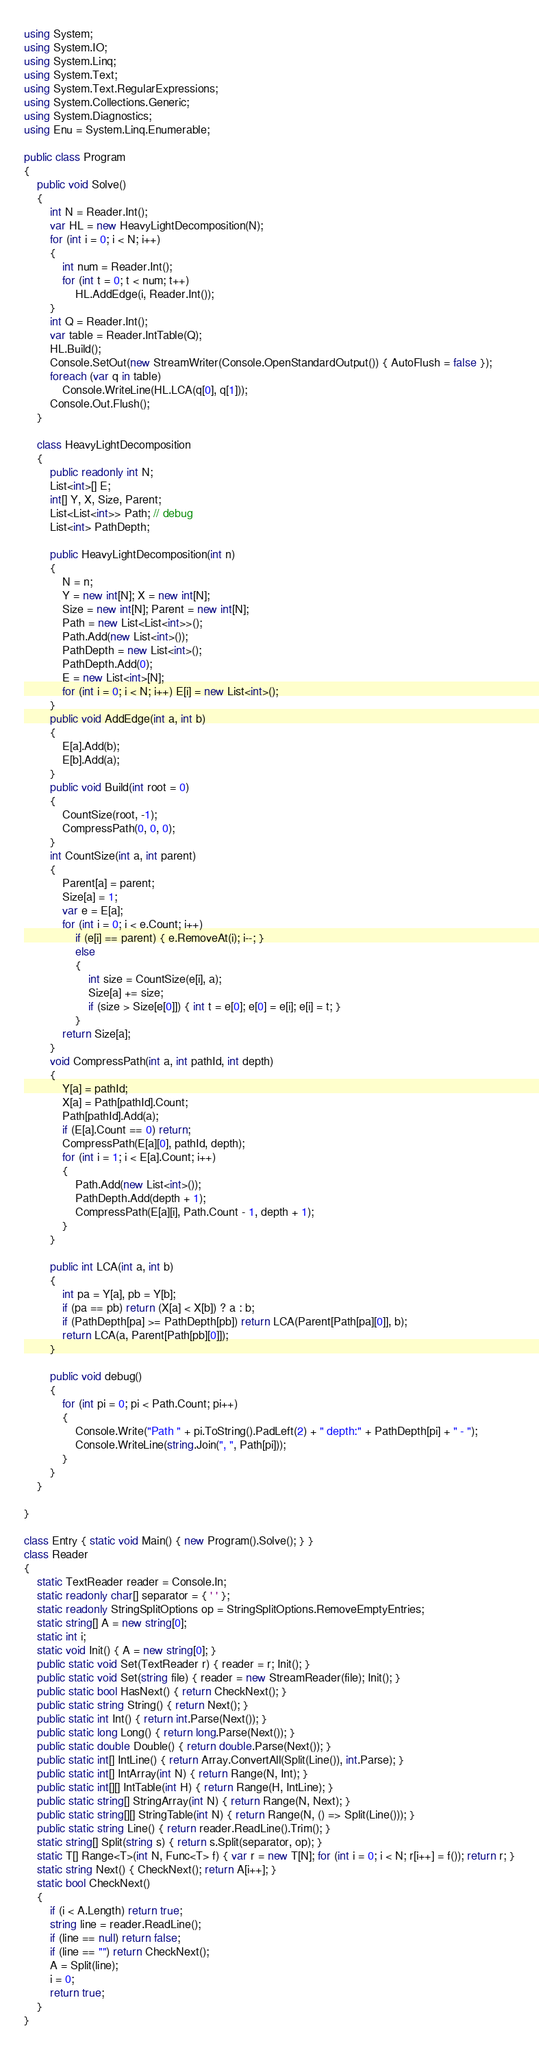<code> <loc_0><loc_0><loc_500><loc_500><_C#_>using System;
using System.IO;
using System.Linq;
using System.Text;
using System.Text.RegularExpressions;
using System.Collections.Generic;
using System.Diagnostics;
using Enu = System.Linq.Enumerable;

public class Program
{
    public void Solve()
    {
        int N = Reader.Int();
        var HL = new HeavyLightDecomposition(N);
        for (int i = 0; i < N; i++)
        {
            int num = Reader.Int();
            for (int t = 0; t < num; t++)
                HL.AddEdge(i, Reader.Int());
        }
        int Q = Reader.Int();
        var table = Reader.IntTable(Q);
        HL.Build();
        Console.SetOut(new StreamWriter(Console.OpenStandardOutput()) { AutoFlush = false });
        foreach (var q in table)
            Console.WriteLine(HL.LCA(q[0], q[1]));
        Console.Out.Flush();
    }

    class HeavyLightDecomposition
    {
        public readonly int N;
        List<int>[] E;
        int[] Y, X, Size, Parent;
        List<List<int>> Path; // debug
        List<int> PathDepth;

        public HeavyLightDecomposition(int n)
        {
            N = n;
            Y = new int[N]; X = new int[N];
            Size = new int[N]; Parent = new int[N];
            Path = new List<List<int>>();
            Path.Add(new List<int>());
            PathDepth = new List<int>();
            PathDepth.Add(0);
            E = new List<int>[N];
            for (int i = 0; i < N; i++) E[i] = new List<int>();
        }
        public void AddEdge(int a, int b)
        {
            E[a].Add(b);
            E[b].Add(a);
        }
        public void Build(int root = 0)
        {
            CountSize(root, -1);
            CompressPath(0, 0, 0);
        }
        int CountSize(int a, int parent)
        {
            Parent[a] = parent;
            Size[a] = 1;
            var e = E[a];
            for (int i = 0; i < e.Count; i++)
                if (e[i] == parent) { e.RemoveAt(i); i--; }
                else
                {
                    int size = CountSize(e[i], a);
                    Size[a] += size;
                    if (size > Size[e[0]]) { int t = e[0]; e[0] = e[i]; e[i] = t; }
                }
            return Size[a];
        }
        void CompressPath(int a, int pathId, int depth)
        {
            Y[a] = pathId;
            X[a] = Path[pathId].Count;
            Path[pathId].Add(a);
            if (E[a].Count == 0) return;
            CompressPath(E[a][0], pathId, depth);
            for (int i = 1; i < E[a].Count; i++)
            {
                Path.Add(new List<int>());
                PathDepth.Add(depth + 1);
                CompressPath(E[a][i], Path.Count - 1, depth + 1);
            }
        }

        public int LCA(int a, int b)
        {
            int pa = Y[a], pb = Y[b];
            if (pa == pb) return (X[a] < X[b]) ? a : b;
            if (PathDepth[pa] >= PathDepth[pb]) return LCA(Parent[Path[pa][0]], b);
            return LCA(a, Parent[Path[pb][0]]);
        }

        public void debug()
        {
            for (int pi = 0; pi < Path.Count; pi++)
            {
                Console.Write("Path " + pi.ToString().PadLeft(2) + " depth:" + PathDepth[pi] + " - ");
                Console.WriteLine(string.Join(", ", Path[pi]));
            }
        }
    }

}

class Entry { static void Main() { new Program().Solve(); } }
class Reader
{
    static TextReader reader = Console.In;
    static readonly char[] separator = { ' ' };
    static readonly StringSplitOptions op = StringSplitOptions.RemoveEmptyEntries;
    static string[] A = new string[0];
    static int i;
    static void Init() { A = new string[0]; }
    public static void Set(TextReader r) { reader = r; Init(); }
    public static void Set(string file) { reader = new StreamReader(file); Init(); }
    public static bool HasNext() { return CheckNext(); }
    public static string String() { return Next(); }
    public static int Int() { return int.Parse(Next()); }
    public static long Long() { return long.Parse(Next()); }
    public static double Double() { return double.Parse(Next()); }
    public static int[] IntLine() { return Array.ConvertAll(Split(Line()), int.Parse); }
    public static int[] IntArray(int N) { return Range(N, Int); }
    public static int[][] IntTable(int H) { return Range(H, IntLine); }
    public static string[] StringArray(int N) { return Range(N, Next); }
    public static string[][] StringTable(int N) { return Range(N, () => Split(Line())); }
    public static string Line() { return reader.ReadLine().Trim(); }
    static string[] Split(string s) { return s.Split(separator, op); }
    static T[] Range<T>(int N, Func<T> f) { var r = new T[N]; for (int i = 0; i < N; r[i++] = f()); return r; }
    static string Next() { CheckNext(); return A[i++]; }
    static bool CheckNext()
    {
        if (i < A.Length) return true;
        string line = reader.ReadLine();
        if (line == null) return false;
        if (line == "") return CheckNext();
        A = Split(line);
        i = 0;
        return true;
    }
}</code> 